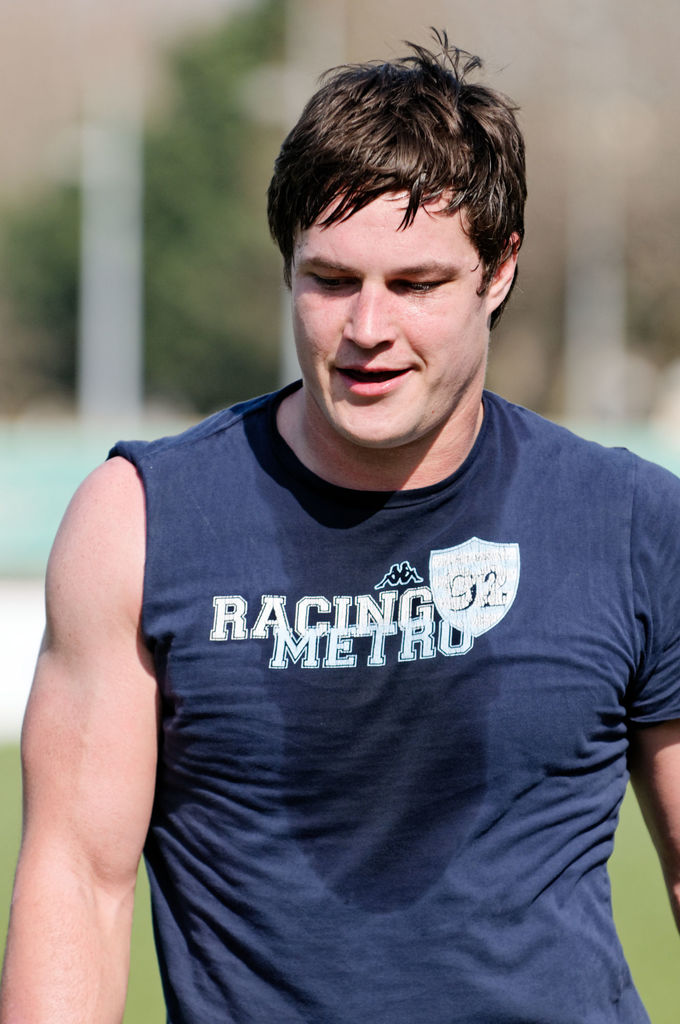Provide a one-sentence caption for the provided image. A man appears to be taking a break during an outdoor sports training session, wearing a 'RACING METRO 92' sleeveless training shirt, indicating he may be a part of the sports team or a fan. 